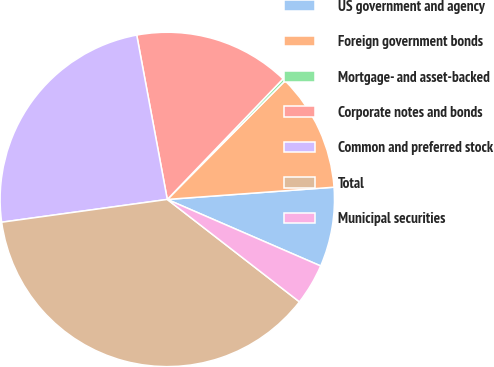Convert chart to OTSL. <chart><loc_0><loc_0><loc_500><loc_500><pie_chart><fcel>US government and agency<fcel>Foreign government bonds<fcel>Mortgage- and asset-backed<fcel>Corporate notes and bonds<fcel>Common and preferred stock<fcel>Total<fcel>Municipal securities<nl><fcel>7.68%<fcel>11.39%<fcel>0.27%<fcel>15.1%<fcel>24.25%<fcel>37.33%<fcel>3.98%<nl></chart> 